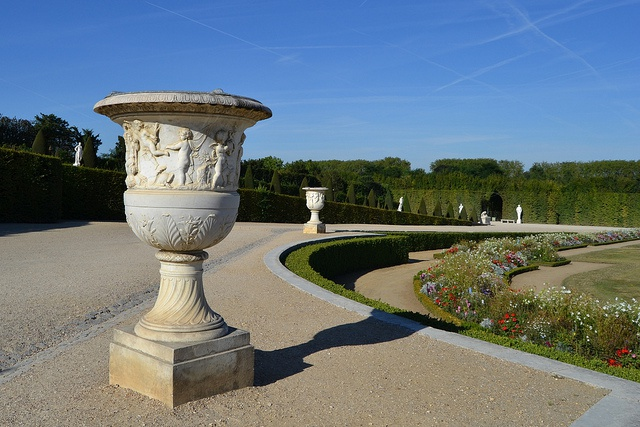Describe the objects in this image and their specific colors. I can see vase in blue, darkgray, gray, tan, and lightgray tones and vase in blue, ivory, tan, gray, and darkgray tones in this image. 